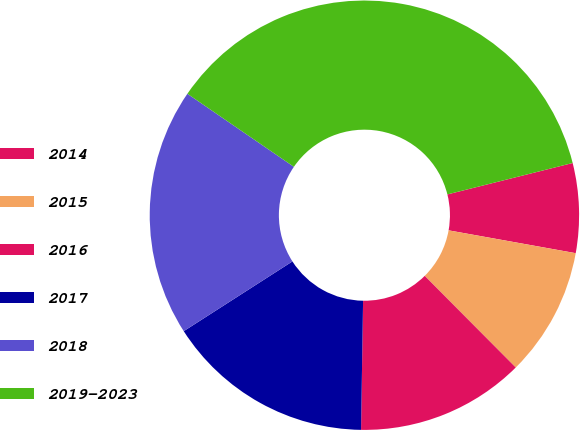Convert chart to OTSL. <chart><loc_0><loc_0><loc_500><loc_500><pie_chart><fcel>2014<fcel>2015<fcel>2016<fcel>2017<fcel>2018<fcel>2019-2023<nl><fcel>6.74%<fcel>9.72%<fcel>12.7%<fcel>15.67%<fcel>18.65%<fcel>36.52%<nl></chart> 